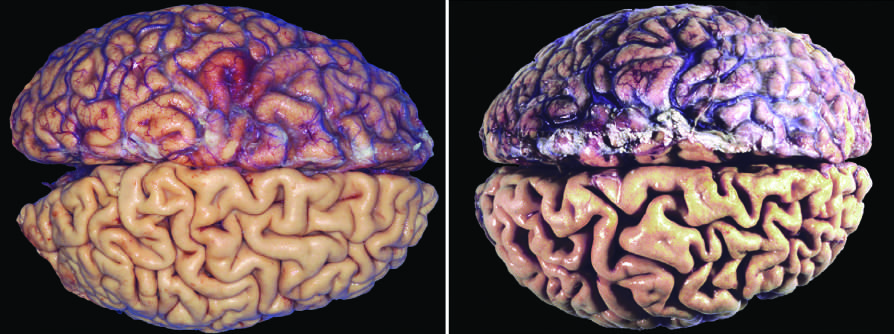have the necrotic cells been stripped from the bottom half of each specimen to show the surface of the brain?
Answer the question using a single word or phrase. No 